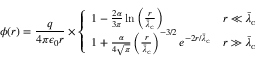Convert formula to latex. <formula><loc_0><loc_0><loc_500><loc_500>\phi ( r ) = { \frac { q } { 4 \pi \epsilon _ { 0 } r } } \times { \left \{ \begin{array} { l l } { 1 - { \frac { 2 \alpha } { 3 \pi } } \ln \left ( { \frac { r } { { \bar { \lambda } } _ { c } } } \right ) } & { r \ll { \bar { \lambda } } _ { c } } \\ { 1 + { \frac { \alpha } { 4 { \sqrt { \pi } } } } \left ( { \frac { r } { { \bar { \lambda } } _ { c } } } \right ) ^ { - 3 / 2 } e ^ { - 2 r / { \bar { \lambda } } _ { c } } } & { r \gg { \bar { \lambda } } _ { c } } \end{array} }</formula> 